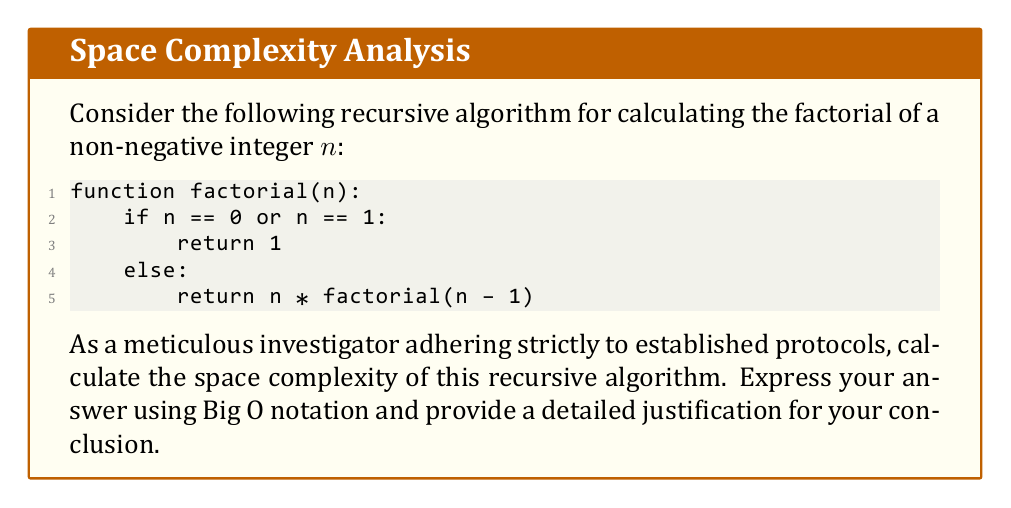Teach me how to tackle this problem. To calculate the space complexity of this recursive algorithm, we need to follow a systematic approach:

1. Identify the recursive call stack:
   The primary contributor to space complexity in recursive algorithms is the call stack. Each recursive call adds a new frame to the stack.

2. Analyze the maximum depth of recursion:
   The recursion continues until $n$ reaches 0 or 1. For an input $n$, the number of recursive calls is $n$.

3. Examine the space used by each stack frame:
   Each stack frame contains:
   - The parameter $n$
   - The return address
   - Local variables (none in this case)

   The space used by each frame is constant, let's denote it as $c$.

4. Calculate the total space used:
   Total space = Space per frame × Number of frames
   $$ S(n) = c \times n $$

5. Express in Big O notation:
   Since $c$ is a constant, we can simplify the expression to:
   $$ O(n) $$

6. Consider the base case:
   The base case (when $n = 0$ or $n = 1$) uses constant space, which is already accounted for in our $O(n)$ notation.

7. Verify the protocol:
   Our analysis follows the standard procedure for calculating space complexity of recursive algorithms, adhering to established computer science principles.
Answer: The space complexity of the given recursive factorial algorithm is $O(n)$, where $n$ is the input value. 